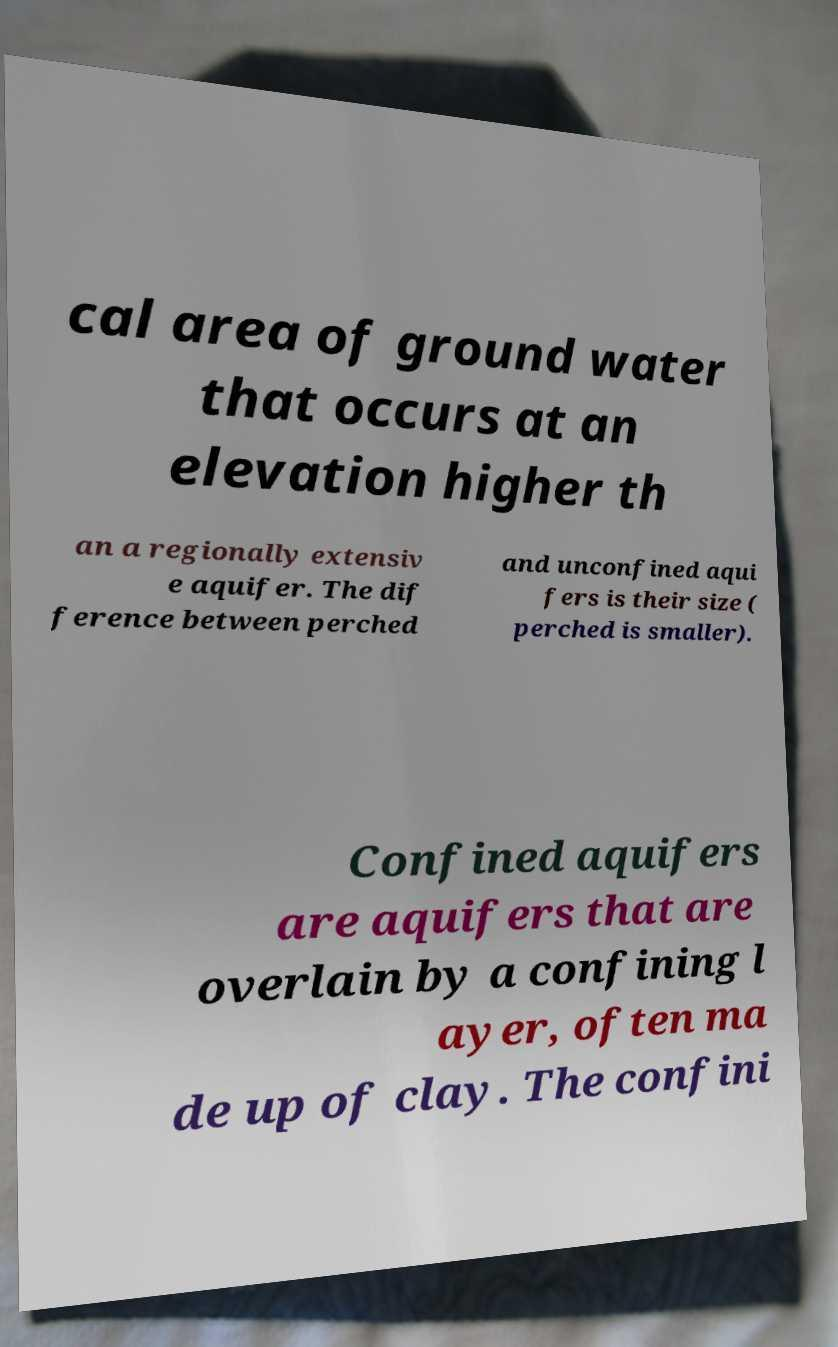Please read and relay the text visible in this image. What does it say? cal area of ground water that occurs at an elevation higher th an a regionally extensiv e aquifer. The dif ference between perched and unconfined aqui fers is their size ( perched is smaller). Confined aquifers are aquifers that are overlain by a confining l ayer, often ma de up of clay. The confini 